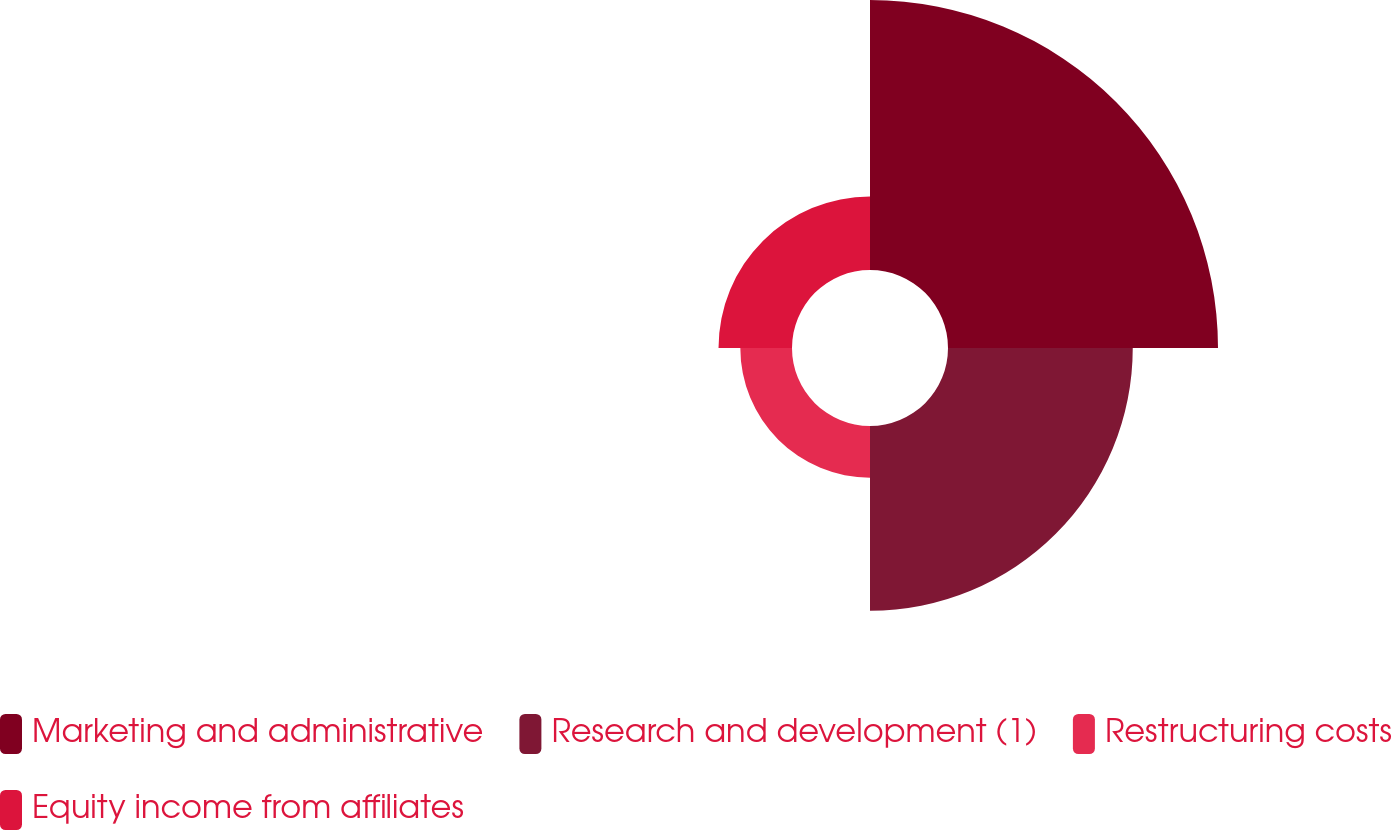Convert chart to OTSL. <chart><loc_0><loc_0><loc_500><loc_500><pie_chart><fcel>Marketing and administrative<fcel>Research and development (1)<fcel>Restructuring costs<fcel>Equity income from affiliates<nl><fcel>46.56%<fcel>31.86%<fcel>8.91%<fcel>12.67%<nl></chart> 